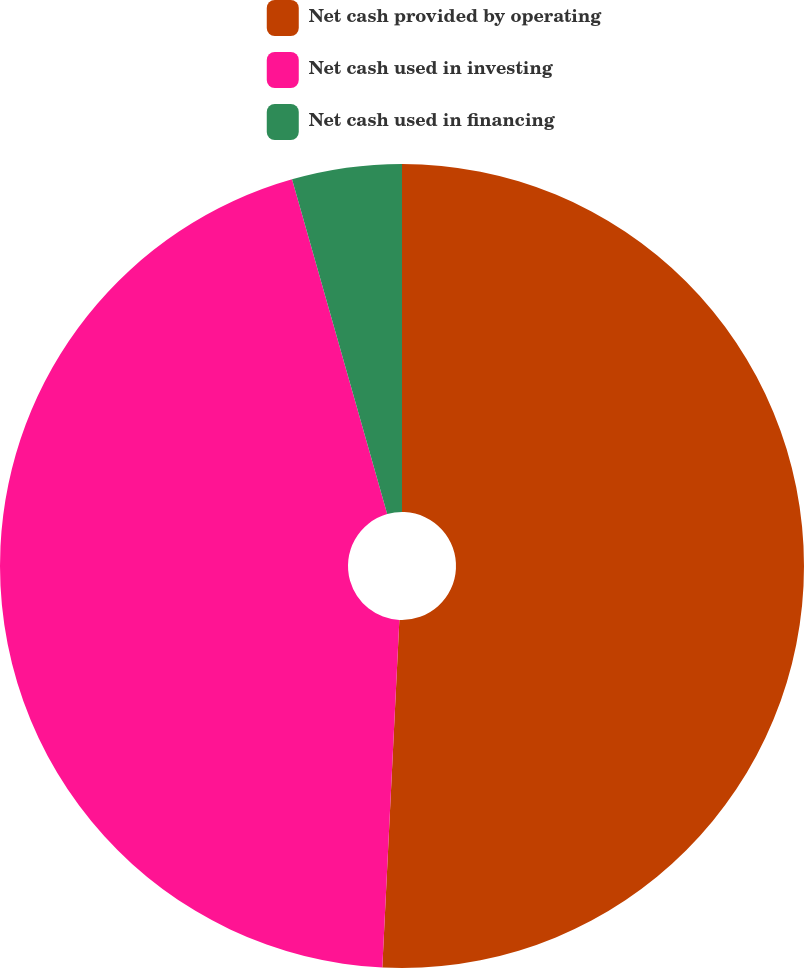Convert chart. <chart><loc_0><loc_0><loc_500><loc_500><pie_chart><fcel>Net cash provided by operating<fcel>Net cash used in investing<fcel>Net cash used in financing<nl><fcel>50.78%<fcel>44.81%<fcel>4.41%<nl></chart> 